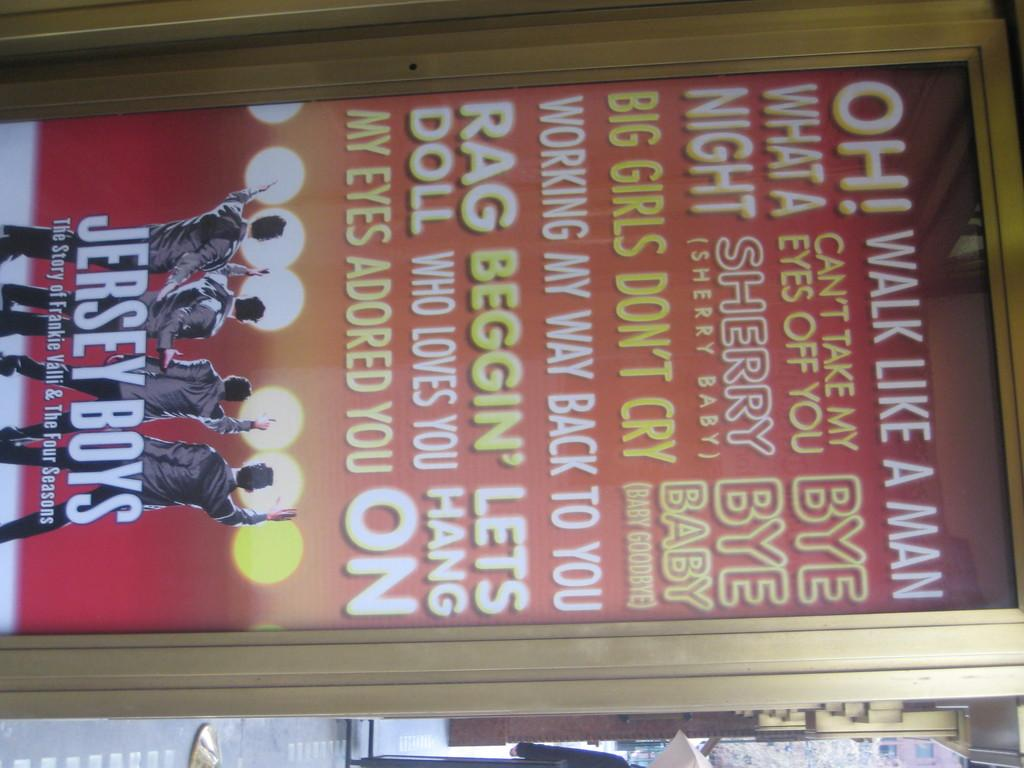<image>
Provide a brief description of the given image. A poster for Jersey Boys is displayed on the street. 